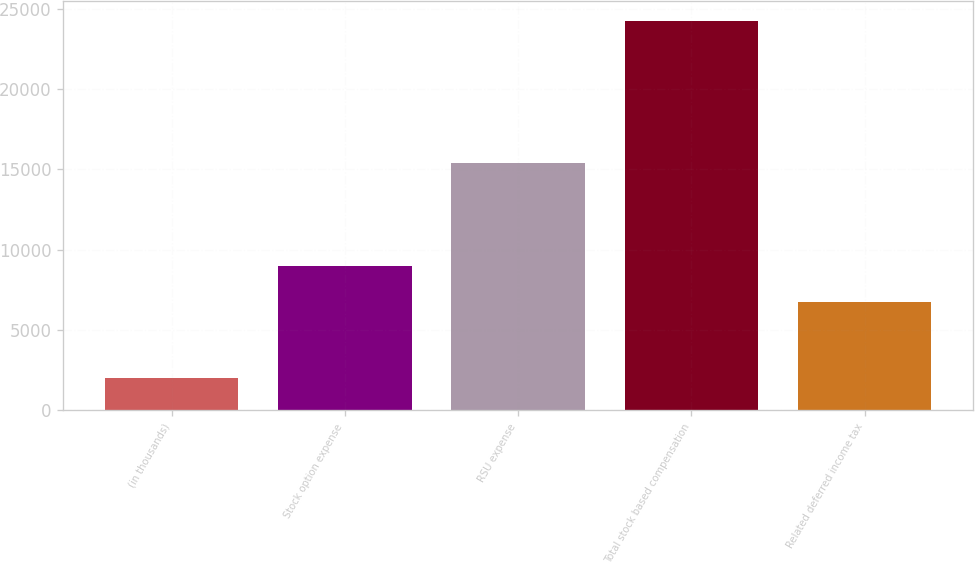Convert chart to OTSL. <chart><loc_0><loc_0><loc_500><loc_500><bar_chart><fcel>(in thousands)<fcel>Stock option expense<fcel>RSU expense<fcel>Total stock based compensation<fcel>Related deferred income tax<nl><fcel>2014<fcel>8966.3<fcel>15399<fcel>24237<fcel>6744<nl></chart> 